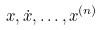Convert formula to latex. <formula><loc_0><loc_0><loc_500><loc_500>x , \dot { x } , \dots , x ^ { ( n ) }</formula> 